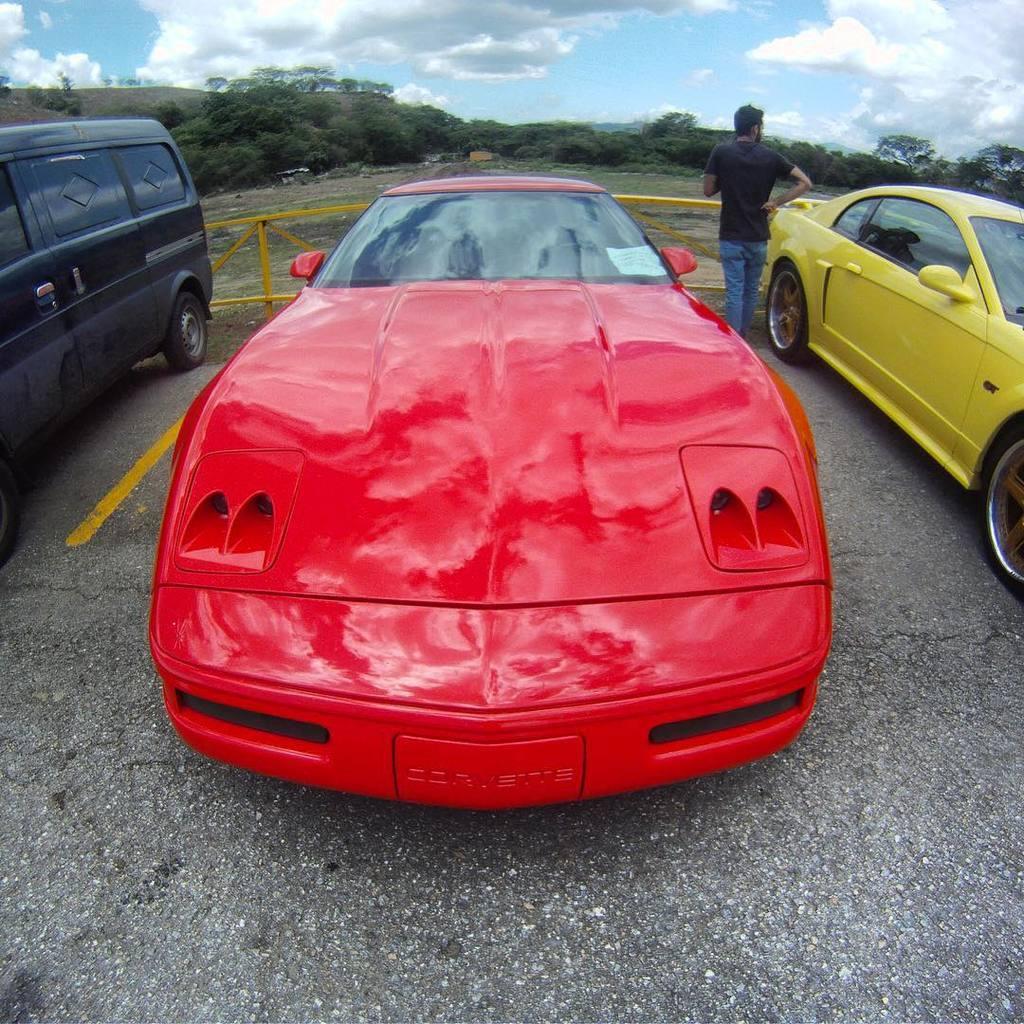Please provide a concise description of this image. In this image, we can see three vehicles are parked on the path. Here a person is standing. Background we can see fence, trees, plants, ground and cloudy sky. 